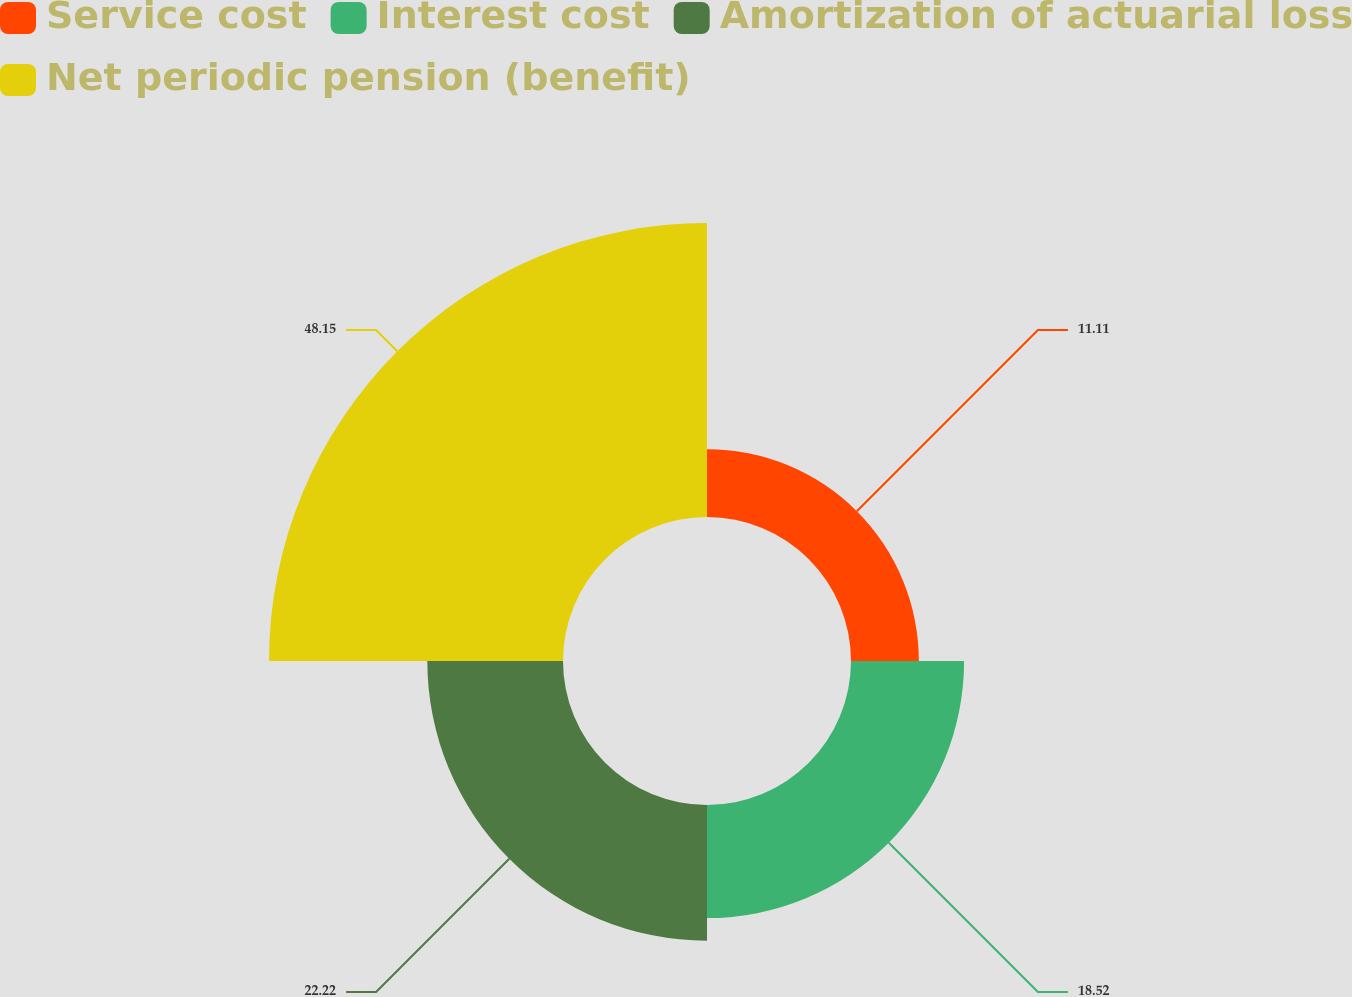<chart> <loc_0><loc_0><loc_500><loc_500><pie_chart><fcel>Service cost<fcel>Interest cost<fcel>Amortization of actuarial loss<fcel>Net periodic pension (benefit)<nl><fcel>11.11%<fcel>18.52%<fcel>22.22%<fcel>48.15%<nl></chart> 